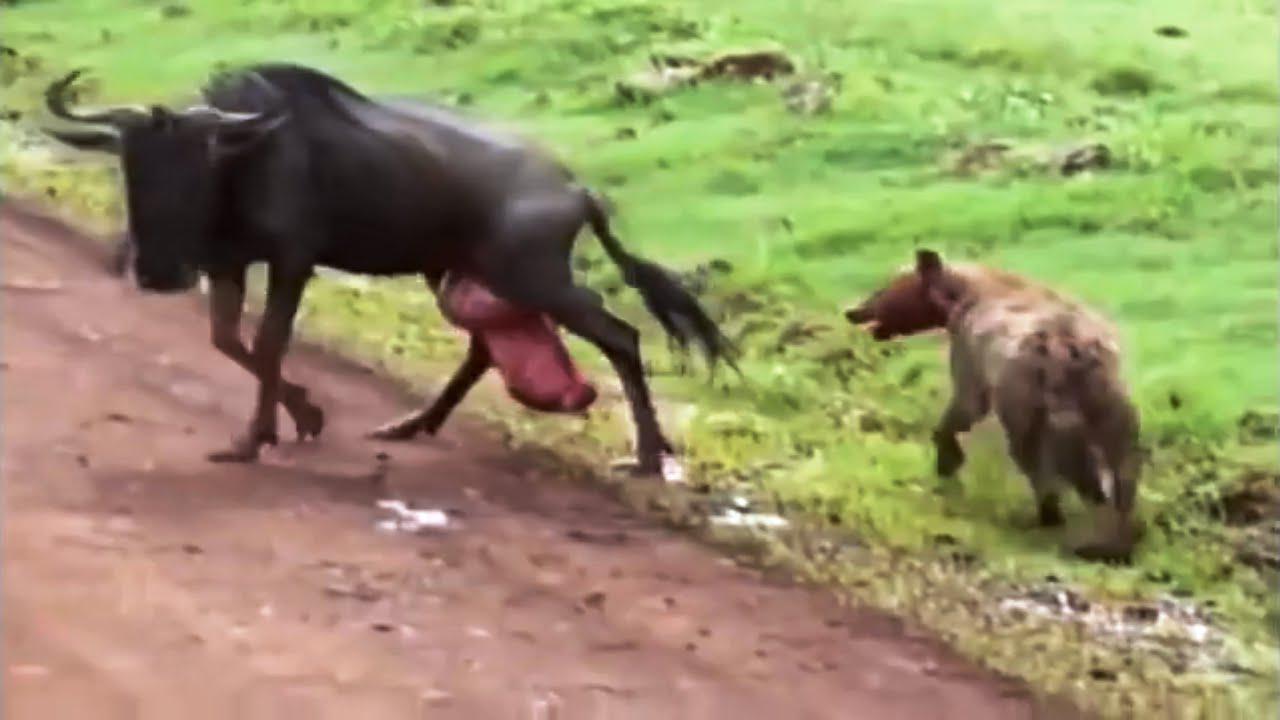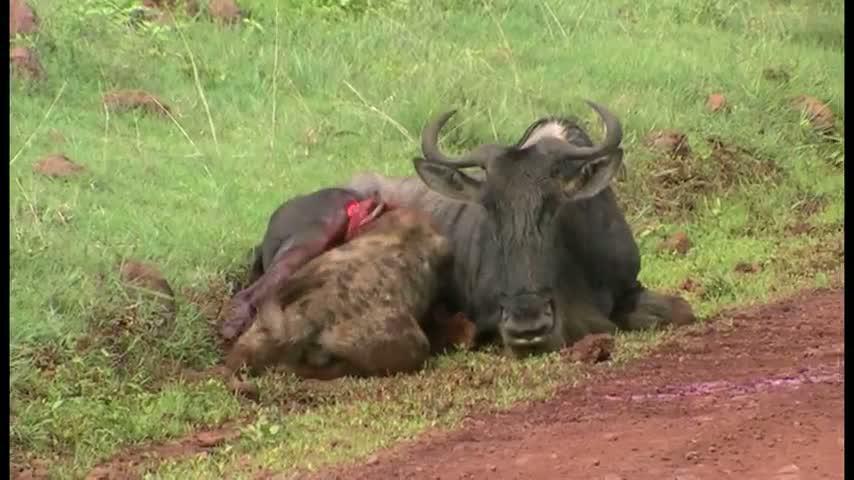The first image is the image on the left, the second image is the image on the right. Considering the images on both sides, is "An animal is laying bleeding in the image on the right." valid? Answer yes or no. Yes. 